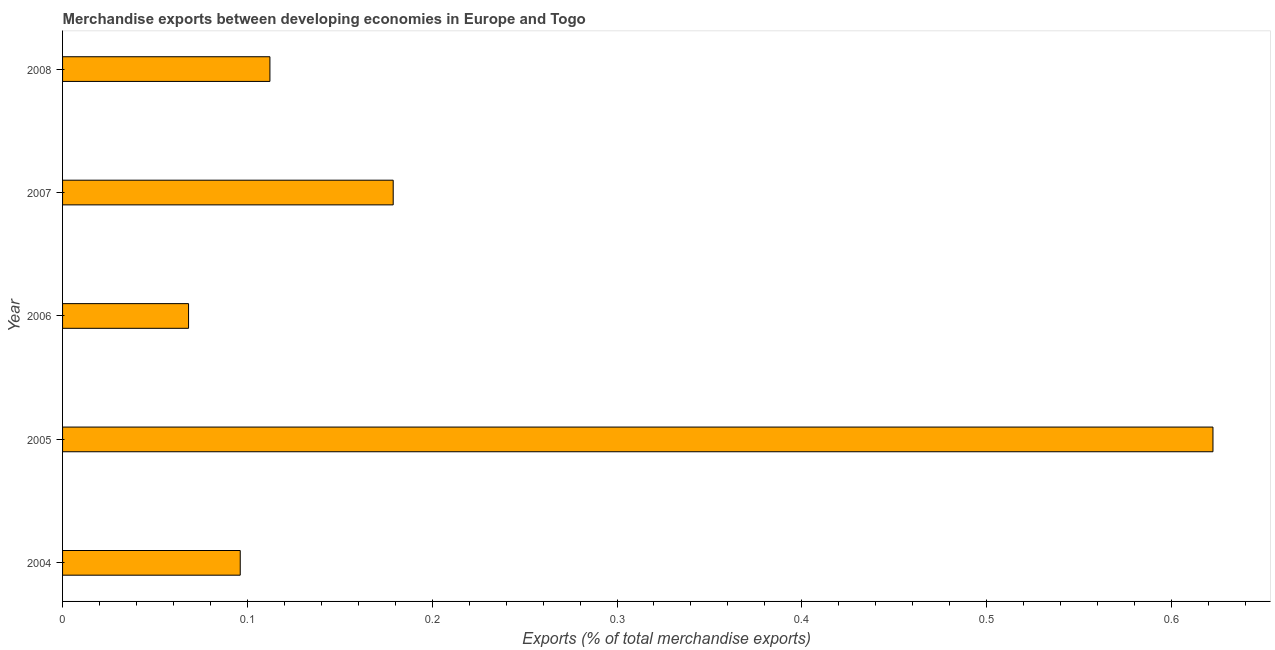Does the graph contain any zero values?
Keep it short and to the point. No. Does the graph contain grids?
Your answer should be compact. No. What is the title of the graph?
Your answer should be compact. Merchandise exports between developing economies in Europe and Togo. What is the label or title of the X-axis?
Provide a short and direct response. Exports (% of total merchandise exports). What is the label or title of the Y-axis?
Your answer should be very brief. Year. What is the merchandise exports in 2008?
Provide a succinct answer. 0.11. Across all years, what is the maximum merchandise exports?
Offer a very short reply. 0.62. Across all years, what is the minimum merchandise exports?
Offer a very short reply. 0.07. In which year was the merchandise exports minimum?
Provide a succinct answer. 2006. What is the sum of the merchandise exports?
Give a very brief answer. 1.08. What is the difference between the merchandise exports in 2004 and 2008?
Your answer should be compact. -0.02. What is the average merchandise exports per year?
Provide a succinct answer. 0.22. What is the median merchandise exports?
Offer a terse response. 0.11. What is the ratio of the merchandise exports in 2005 to that in 2007?
Make the answer very short. 3.48. What is the difference between the highest and the second highest merchandise exports?
Provide a succinct answer. 0.44. What is the difference between the highest and the lowest merchandise exports?
Offer a terse response. 0.55. In how many years, is the merchandise exports greater than the average merchandise exports taken over all years?
Ensure brevity in your answer.  1. How many bars are there?
Provide a short and direct response. 5. Are all the bars in the graph horizontal?
Make the answer very short. Yes. What is the difference between two consecutive major ticks on the X-axis?
Make the answer very short. 0.1. Are the values on the major ticks of X-axis written in scientific E-notation?
Make the answer very short. No. What is the Exports (% of total merchandise exports) in 2004?
Offer a very short reply. 0.1. What is the Exports (% of total merchandise exports) in 2005?
Your answer should be very brief. 0.62. What is the Exports (% of total merchandise exports) of 2006?
Keep it short and to the point. 0.07. What is the Exports (% of total merchandise exports) of 2007?
Offer a terse response. 0.18. What is the Exports (% of total merchandise exports) of 2008?
Keep it short and to the point. 0.11. What is the difference between the Exports (% of total merchandise exports) in 2004 and 2005?
Your response must be concise. -0.53. What is the difference between the Exports (% of total merchandise exports) in 2004 and 2006?
Provide a short and direct response. 0.03. What is the difference between the Exports (% of total merchandise exports) in 2004 and 2007?
Your answer should be compact. -0.08. What is the difference between the Exports (% of total merchandise exports) in 2004 and 2008?
Make the answer very short. -0.02. What is the difference between the Exports (% of total merchandise exports) in 2005 and 2006?
Your answer should be compact. 0.55. What is the difference between the Exports (% of total merchandise exports) in 2005 and 2007?
Make the answer very short. 0.44. What is the difference between the Exports (% of total merchandise exports) in 2005 and 2008?
Offer a very short reply. 0.51. What is the difference between the Exports (% of total merchandise exports) in 2006 and 2007?
Keep it short and to the point. -0.11. What is the difference between the Exports (% of total merchandise exports) in 2006 and 2008?
Provide a short and direct response. -0.04. What is the difference between the Exports (% of total merchandise exports) in 2007 and 2008?
Provide a short and direct response. 0.07. What is the ratio of the Exports (% of total merchandise exports) in 2004 to that in 2005?
Make the answer very short. 0.15. What is the ratio of the Exports (% of total merchandise exports) in 2004 to that in 2006?
Give a very brief answer. 1.41. What is the ratio of the Exports (% of total merchandise exports) in 2004 to that in 2007?
Make the answer very short. 0.54. What is the ratio of the Exports (% of total merchandise exports) in 2004 to that in 2008?
Your answer should be very brief. 0.86. What is the ratio of the Exports (% of total merchandise exports) in 2005 to that in 2006?
Your answer should be compact. 9.13. What is the ratio of the Exports (% of total merchandise exports) in 2005 to that in 2007?
Ensure brevity in your answer.  3.48. What is the ratio of the Exports (% of total merchandise exports) in 2005 to that in 2008?
Provide a succinct answer. 5.55. What is the ratio of the Exports (% of total merchandise exports) in 2006 to that in 2007?
Provide a succinct answer. 0.38. What is the ratio of the Exports (% of total merchandise exports) in 2006 to that in 2008?
Offer a very short reply. 0.61. What is the ratio of the Exports (% of total merchandise exports) in 2007 to that in 2008?
Your answer should be compact. 1.59. 